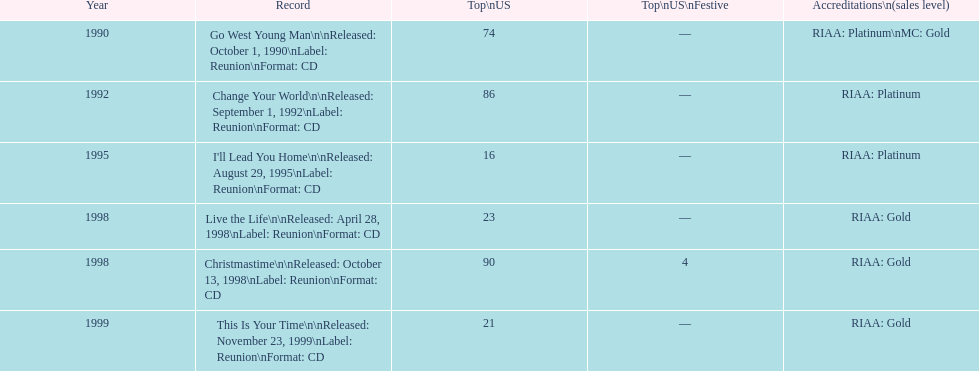What year comes after 1995? 1998. 